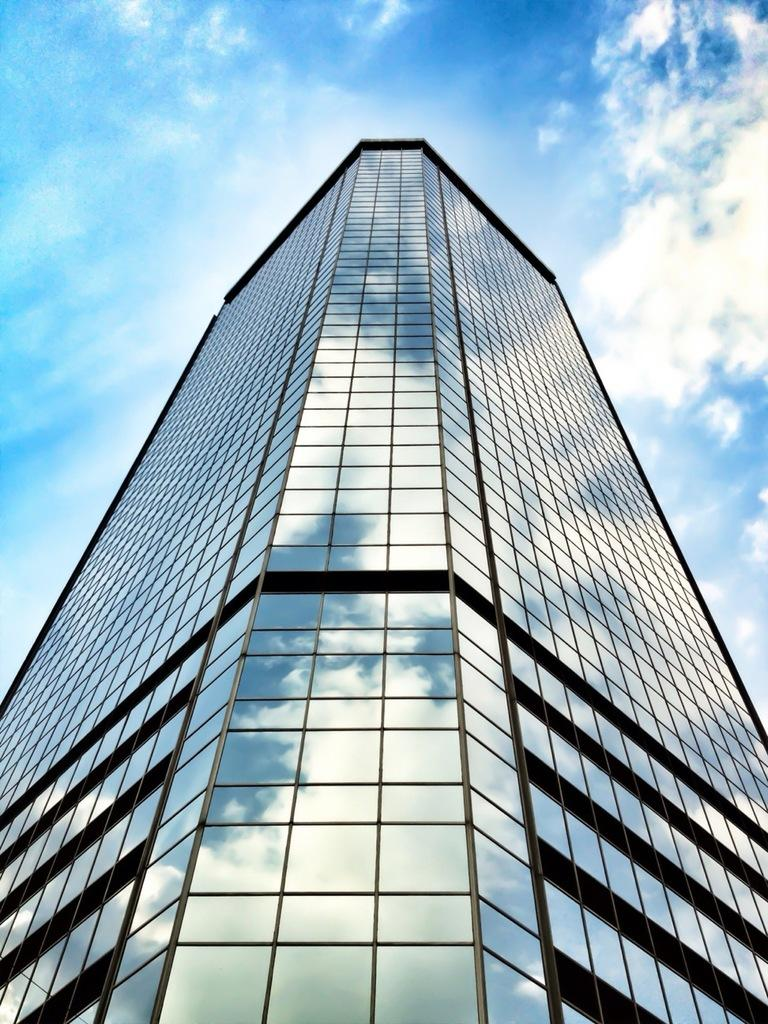What type of building is featured in the image? There is a glass building in the image. What can be seen in the background of the image? The sky in the background is blue and white in color. How many women are present in the image with their pets in the cellar? There are no women, pets, or cellars present in the image; it features a glass building with a blue and white sky in the background. 